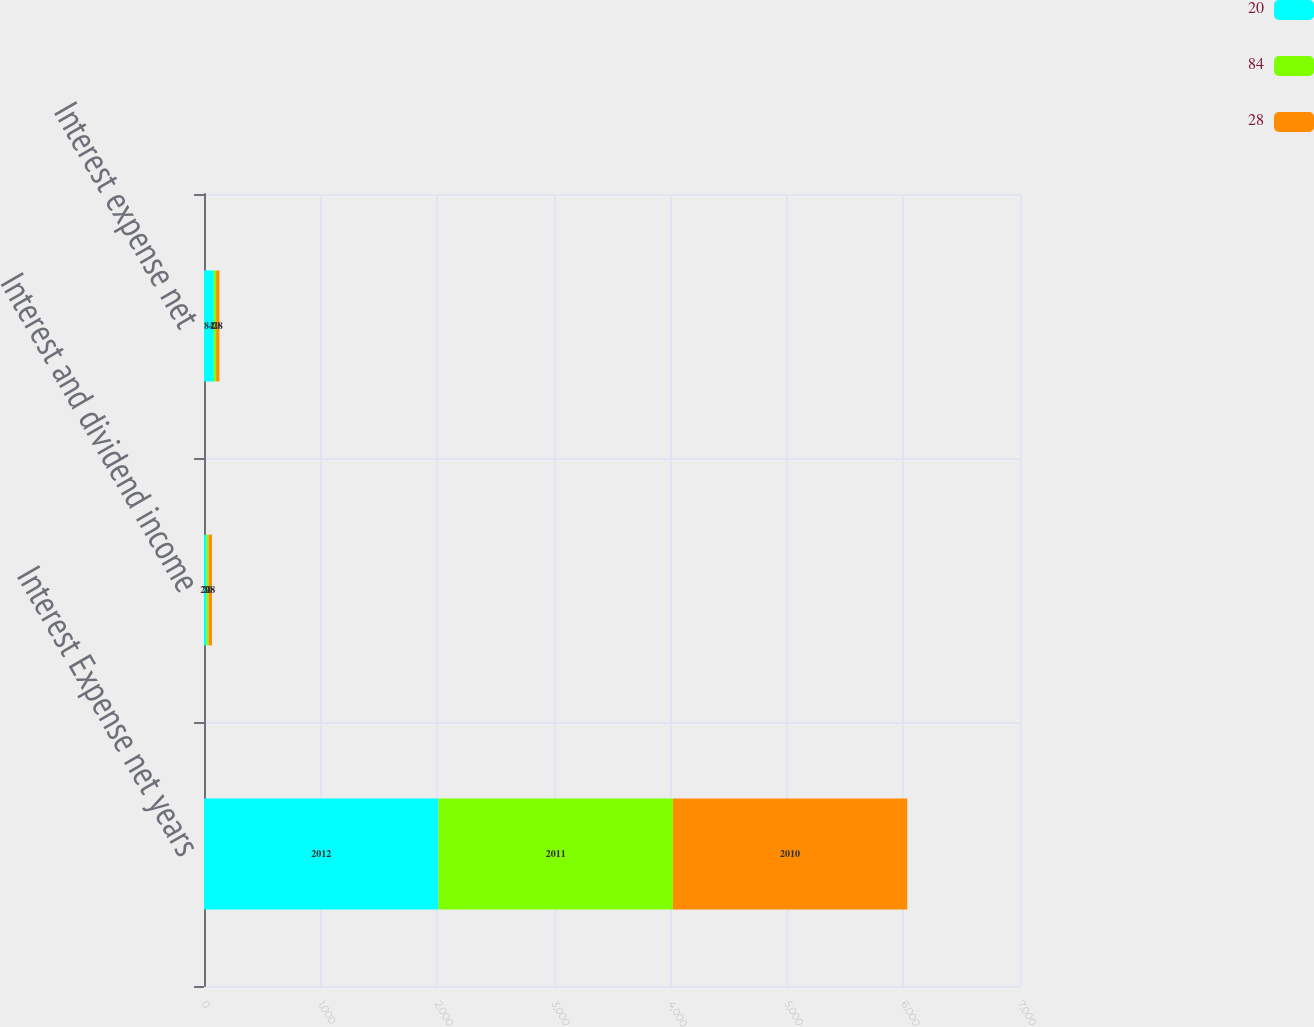<chart> <loc_0><loc_0><loc_500><loc_500><stacked_bar_chart><ecel><fcel>Interest Expense net years<fcel>Interest and dividend income<fcel>Interest expense net<nl><fcel>20<fcel>2012<fcel>20<fcel>84<nl><fcel>84<fcel>2011<fcel>20<fcel>20<nl><fcel>28<fcel>2010<fcel>28<fcel>28<nl></chart> 